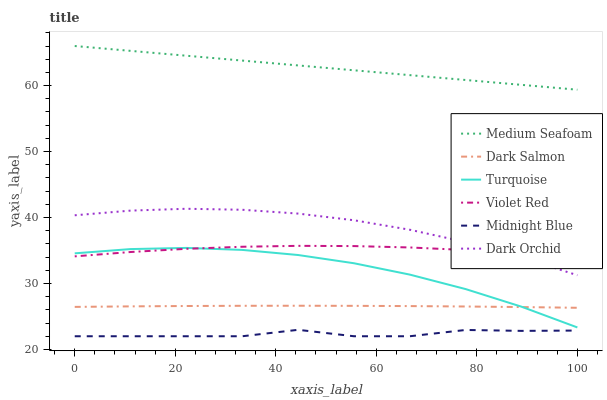Does Midnight Blue have the minimum area under the curve?
Answer yes or no. Yes. Does Medium Seafoam have the maximum area under the curve?
Answer yes or no. Yes. Does Turquoise have the minimum area under the curve?
Answer yes or no. No. Does Turquoise have the maximum area under the curve?
Answer yes or no. No. Is Medium Seafoam the smoothest?
Answer yes or no. Yes. Is Midnight Blue the roughest?
Answer yes or no. Yes. Is Turquoise the smoothest?
Answer yes or no. No. Is Turquoise the roughest?
Answer yes or no. No. Does Midnight Blue have the lowest value?
Answer yes or no. Yes. Does Turquoise have the lowest value?
Answer yes or no. No. Does Medium Seafoam have the highest value?
Answer yes or no. Yes. Does Turquoise have the highest value?
Answer yes or no. No. Is Midnight Blue less than Dark Orchid?
Answer yes or no. Yes. Is Medium Seafoam greater than Violet Red?
Answer yes or no. Yes. Does Turquoise intersect Dark Salmon?
Answer yes or no. Yes. Is Turquoise less than Dark Salmon?
Answer yes or no. No. Is Turquoise greater than Dark Salmon?
Answer yes or no. No. Does Midnight Blue intersect Dark Orchid?
Answer yes or no. No. 